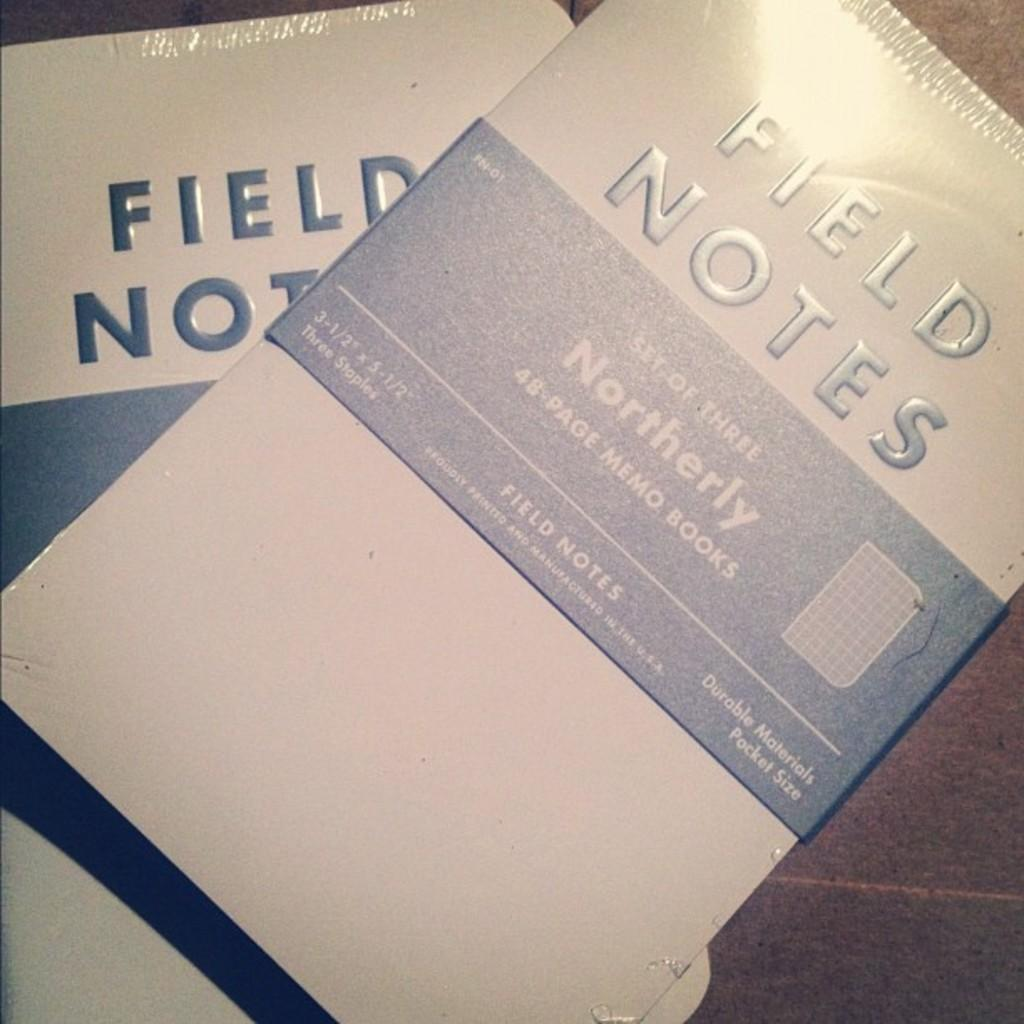<image>
Present a compact description of the photo's key features. A white and blue booklet that is titled, "Field Notes." 